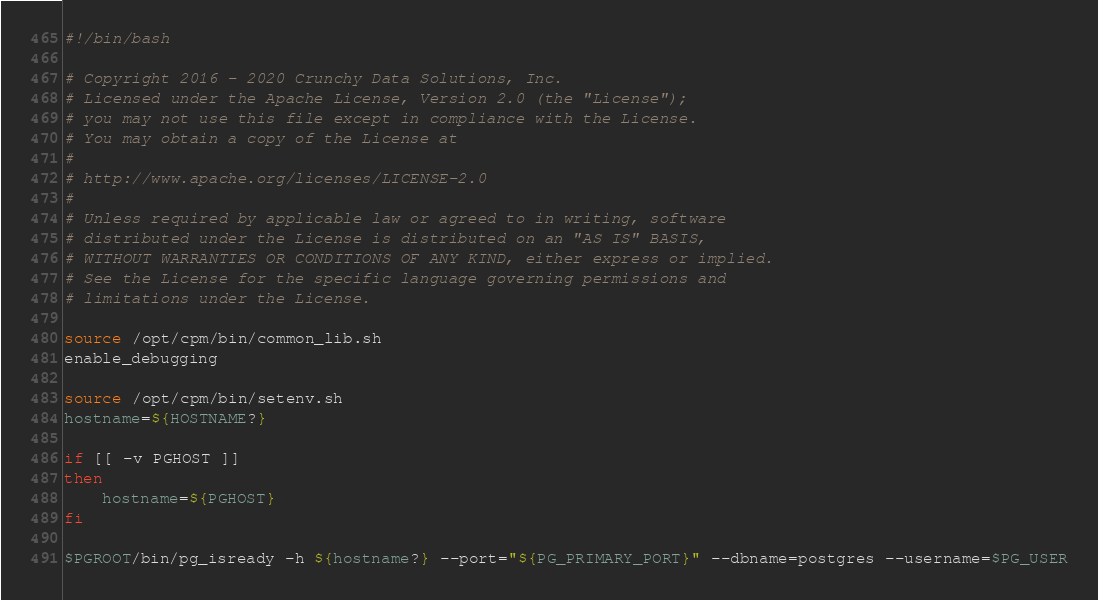Convert code to text. <code><loc_0><loc_0><loc_500><loc_500><_Bash_>#!/bin/bash

# Copyright 2016 - 2020 Crunchy Data Solutions, Inc.
# Licensed under the Apache License, Version 2.0 (the "License");
# you may not use this file except in compliance with the License.
# You may obtain a copy of the License at
#
# http://www.apache.org/licenses/LICENSE-2.0
#
# Unless required by applicable law or agreed to in writing, software
# distributed under the License is distributed on an "AS IS" BASIS,
# WITHOUT WARRANTIES OR CONDITIONS OF ANY KIND, either express or implied.
# See the License for the specific language governing permissions and
# limitations under the License.

source /opt/cpm/bin/common_lib.sh
enable_debugging

source /opt/cpm/bin/setenv.sh
hostname=${HOSTNAME?}

if [[ -v PGHOST ]]
then
    hostname=${PGHOST}
fi

$PGROOT/bin/pg_isready -h ${hostname?} --port="${PG_PRIMARY_PORT}" --dbname=postgres --username=$PG_USER
</code> 